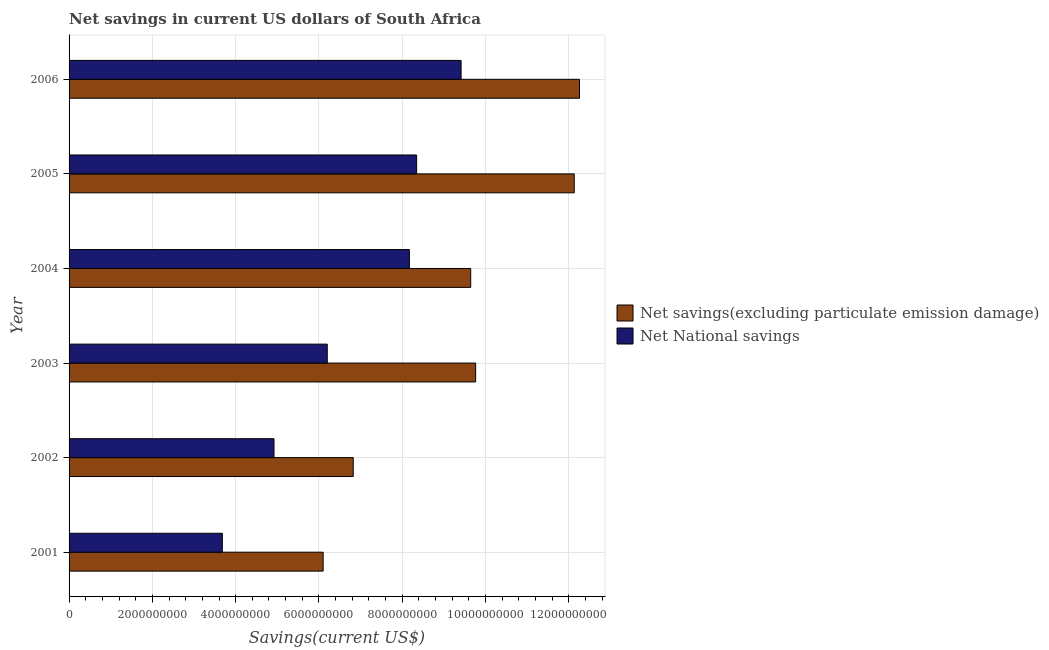Are the number of bars on each tick of the Y-axis equal?
Your response must be concise. Yes. In how many cases, is the number of bars for a given year not equal to the number of legend labels?
Your answer should be compact. 0. What is the net national savings in 2005?
Ensure brevity in your answer.  8.35e+09. Across all years, what is the maximum net savings(excluding particulate emission damage)?
Offer a very short reply. 1.23e+1. Across all years, what is the minimum net national savings?
Offer a terse response. 3.68e+09. What is the total net savings(excluding particulate emission damage) in the graph?
Ensure brevity in your answer.  5.67e+1. What is the difference between the net savings(excluding particulate emission damage) in 2003 and that in 2005?
Your answer should be very brief. -2.37e+09. What is the difference between the net national savings in 2002 and the net savings(excluding particulate emission damage) in 2005?
Provide a short and direct response. -7.21e+09. What is the average net national savings per year?
Give a very brief answer. 6.79e+09. In the year 2006, what is the difference between the net savings(excluding particulate emission damage) and net national savings?
Offer a terse response. 2.84e+09. What is the ratio of the net savings(excluding particulate emission damage) in 2001 to that in 2004?
Make the answer very short. 0.63. What is the difference between the highest and the second highest net national savings?
Make the answer very short. 1.07e+09. What is the difference between the highest and the lowest net national savings?
Provide a succinct answer. 5.73e+09. What does the 2nd bar from the top in 2003 represents?
Your answer should be compact. Net savings(excluding particulate emission damage). What does the 1st bar from the bottom in 2005 represents?
Your answer should be very brief. Net savings(excluding particulate emission damage). How many bars are there?
Provide a short and direct response. 12. What is the difference between two consecutive major ticks on the X-axis?
Provide a short and direct response. 2.00e+09. Does the graph contain any zero values?
Provide a succinct answer. No. How are the legend labels stacked?
Ensure brevity in your answer.  Vertical. What is the title of the graph?
Your answer should be very brief. Net savings in current US dollars of South Africa. What is the label or title of the X-axis?
Keep it short and to the point. Savings(current US$). What is the label or title of the Y-axis?
Provide a short and direct response. Year. What is the Savings(current US$) in Net savings(excluding particulate emission damage) in 2001?
Provide a succinct answer. 6.10e+09. What is the Savings(current US$) in Net National savings in 2001?
Your answer should be compact. 3.68e+09. What is the Savings(current US$) in Net savings(excluding particulate emission damage) in 2002?
Make the answer very short. 6.82e+09. What is the Savings(current US$) in Net National savings in 2002?
Offer a very short reply. 4.92e+09. What is the Savings(current US$) in Net savings(excluding particulate emission damage) in 2003?
Your answer should be compact. 9.76e+09. What is the Savings(current US$) in Net National savings in 2003?
Offer a terse response. 6.20e+09. What is the Savings(current US$) in Net savings(excluding particulate emission damage) in 2004?
Keep it short and to the point. 9.64e+09. What is the Savings(current US$) of Net National savings in 2004?
Ensure brevity in your answer.  8.17e+09. What is the Savings(current US$) of Net savings(excluding particulate emission damage) in 2005?
Provide a short and direct response. 1.21e+1. What is the Savings(current US$) in Net National savings in 2005?
Provide a short and direct response. 8.35e+09. What is the Savings(current US$) of Net savings(excluding particulate emission damage) in 2006?
Keep it short and to the point. 1.23e+1. What is the Savings(current US$) in Net National savings in 2006?
Your answer should be compact. 9.41e+09. Across all years, what is the maximum Savings(current US$) of Net savings(excluding particulate emission damage)?
Make the answer very short. 1.23e+1. Across all years, what is the maximum Savings(current US$) of Net National savings?
Your response must be concise. 9.41e+09. Across all years, what is the minimum Savings(current US$) in Net savings(excluding particulate emission damage)?
Give a very brief answer. 6.10e+09. Across all years, what is the minimum Savings(current US$) in Net National savings?
Provide a succinct answer. 3.68e+09. What is the total Savings(current US$) in Net savings(excluding particulate emission damage) in the graph?
Offer a very short reply. 5.67e+1. What is the total Savings(current US$) in Net National savings in the graph?
Provide a short and direct response. 4.07e+1. What is the difference between the Savings(current US$) of Net savings(excluding particulate emission damage) in 2001 and that in 2002?
Give a very brief answer. -7.22e+08. What is the difference between the Savings(current US$) of Net National savings in 2001 and that in 2002?
Make the answer very short. -1.24e+09. What is the difference between the Savings(current US$) in Net savings(excluding particulate emission damage) in 2001 and that in 2003?
Your answer should be compact. -3.66e+09. What is the difference between the Savings(current US$) in Net National savings in 2001 and that in 2003?
Give a very brief answer. -2.52e+09. What is the difference between the Savings(current US$) in Net savings(excluding particulate emission damage) in 2001 and that in 2004?
Provide a short and direct response. -3.54e+09. What is the difference between the Savings(current US$) of Net National savings in 2001 and that in 2004?
Give a very brief answer. -4.49e+09. What is the difference between the Savings(current US$) in Net savings(excluding particulate emission damage) in 2001 and that in 2005?
Provide a succinct answer. -6.03e+09. What is the difference between the Savings(current US$) of Net National savings in 2001 and that in 2005?
Your answer should be compact. -4.66e+09. What is the difference between the Savings(current US$) of Net savings(excluding particulate emission damage) in 2001 and that in 2006?
Keep it short and to the point. -6.16e+09. What is the difference between the Savings(current US$) in Net National savings in 2001 and that in 2006?
Offer a terse response. -5.73e+09. What is the difference between the Savings(current US$) of Net savings(excluding particulate emission damage) in 2002 and that in 2003?
Provide a succinct answer. -2.94e+09. What is the difference between the Savings(current US$) in Net National savings in 2002 and that in 2003?
Give a very brief answer. -1.28e+09. What is the difference between the Savings(current US$) in Net savings(excluding particulate emission damage) in 2002 and that in 2004?
Your answer should be very brief. -2.82e+09. What is the difference between the Savings(current US$) in Net National savings in 2002 and that in 2004?
Give a very brief answer. -3.25e+09. What is the difference between the Savings(current US$) of Net savings(excluding particulate emission damage) in 2002 and that in 2005?
Your response must be concise. -5.31e+09. What is the difference between the Savings(current US$) of Net National savings in 2002 and that in 2005?
Ensure brevity in your answer.  -3.42e+09. What is the difference between the Savings(current US$) in Net savings(excluding particulate emission damage) in 2002 and that in 2006?
Keep it short and to the point. -5.43e+09. What is the difference between the Savings(current US$) in Net National savings in 2002 and that in 2006?
Give a very brief answer. -4.49e+09. What is the difference between the Savings(current US$) in Net savings(excluding particulate emission damage) in 2003 and that in 2004?
Offer a terse response. 1.19e+08. What is the difference between the Savings(current US$) of Net National savings in 2003 and that in 2004?
Your answer should be compact. -1.97e+09. What is the difference between the Savings(current US$) in Net savings(excluding particulate emission damage) in 2003 and that in 2005?
Your response must be concise. -2.37e+09. What is the difference between the Savings(current US$) in Net National savings in 2003 and that in 2005?
Keep it short and to the point. -2.15e+09. What is the difference between the Savings(current US$) of Net savings(excluding particulate emission damage) in 2003 and that in 2006?
Offer a terse response. -2.49e+09. What is the difference between the Savings(current US$) in Net National savings in 2003 and that in 2006?
Give a very brief answer. -3.21e+09. What is the difference between the Savings(current US$) of Net savings(excluding particulate emission damage) in 2004 and that in 2005?
Your answer should be very brief. -2.49e+09. What is the difference between the Savings(current US$) of Net National savings in 2004 and that in 2005?
Offer a terse response. -1.74e+08. What is the difference between the Savings(current US$) in Net savings(excluding particulate emission damage) in 2004 and that in 2006?
Ensure brevity in your answer.  -2.61e+09. What is the difference between the Savings(current US$) in Net National savings in 2004 and that in 2006?
Provide a succinct answer. -1.24e+09. What is the difference between the Savings(current US$) in Net savings(excluding particulate emission damage) in 2005 and that in 2006?
Your answer should be very brief. -1.26e+08. What is the difference between the Savings(current US$) of Net National savings in 2005 and that in 2006?
Give a very brief answer. -1.07e+09. What is the difference between the Savings(current US$) in Net savings(excluding particulate emission damage) in 2001 and the Savings(current US$) in Net National savings in 2002?
Provide a succinct answer. 1.18e+09. What is the difference between the Savings(current US$) of Net savings(excluding particulate emission damage) in 2001 and the Savings(current US$) of Net National savings in 2003?
Ensure brevity in your answer.  -9.90e+07. What is the difference between the Savings(current US$) of Net savings(excluding particulate emission damage) in 2001 and the Savings(current US$) of Net National savings in 2004?
Give a very brief answer. -2.07e+09. What is the difference between the Savings(current US$) in Net savings(excluding particulate emission damage) in 2001 and the Savings(current US$) in Net National savings in 2005?
Give a very brief answer. -2.24e+09. What is the difference between the Savings(current US$) of Net savings(excluding particulate emission damage) in 2001 and the Savings(current US$) of Net National savings in 2006?
Keep it short and to the point. -3.31e+09. What is the difference between the Savings(current US$) of Net savings(excluding particulate emission damage) in 2002 and the Savings(current US$) of Net National savings in 2003?
Give a very brief answer. 6.23e+08. What is the difference between the Savings(current US$) of Net savings(excluding particulate emission damage) in 2002 and the Savings(current US$) of Net National savings in 2004?
Keep it short and to the point. -1.35e+09. What is the difference between the Savings(current US$) of Net savings(excluding particulate emission damage) in 2002 and the Savings(current US$) of Net National savings in 2005?
Ensure brevity in your answer.  -1.52e+09. What is the difference between the Savings(current US$) in Net savings(excluding particulate emission damage) in 2002 and the Savings(current US$) in Net National savings in 2006?
Your answer should be compact. -2.59e+09. What is the difference between the Savings(current US$) in Net savings(excluding particulate emission damage) in 2003 and the Savings(current US$) in Net National savings in 2004?
Give a very brief answer. 1.59e+09. What is the difference between the Savings(current US$) of Net savings(excluding particulate emission damage) in 2003 and the Savings(current US$) of Net National savings in 2005?
Give a very brief answer. 1.42e+09. What is the difference between the Savings(current US$) of Net savings(excluding particulate emission damage) in 2003 and the Savings(current US$) of Net National savings in 2006?
Your response must be concise. 3.49e+08. What is the difference between the Savings(current US$) of Net savings(excluding particulate emission damage) in 2004 and the Savings(current US$) of Net National savings in 2005?
Give a very brief answer. 1.30e+09. What is the difference between the Savings(current US$) of Net savings(excluding particulate emission damage) in 2004 and the Savings(current US$) of Net National savings in 2006?
Make the answer very short. 2.31e+08. What is the difference between the Savings(current US$) of Net savings(excluding particulate emission damage) in 2005 and the Savings(current US$) of Net National savings in 2006?
Your answer should be compact. 2.72e+09. What is the average Savings(current US$) in Net savings(excluding particulate emission damage) per year?
Make the answer very short. 9.45e+09. What is the average Savings(current US$) of Net National savings per year?
Ensure brevity in your answer.  6.79e+09. In the year 2001, what is the difference between the Savings(current US$) of Net savings(excluding particulate emission damage) and Savings(current US$) of Net National savings?
Ensure brevity in your answer.  2.42e+09. In the year 2002, what is the difference between the Savings(current US$) in Net savings(excluding particulate emission damage) and Savings(current US$) in Net National savings?
Your response must be concise. 1.90e+09. In the year 2003, what is the difference between the Savings(current US$) of Net savings(excluding particulate emission damage) and Savings(current US$) of Net National savings?
Your answer should be compact. 3.56e+09. In the year 2004, what is the difference between the Savings(current US$) of Net savings(excluding particulate emission damage) and Savings(current US$) of Net National savings?
Provide a short and direct response. 1.47e+09. In the year 2005, what is the difference between the Savings(current US$) in Net savings(excluding particulate emission damage) and Savings(current US$) in Net National savings?
Provide a succinct answer. 3.78e+09. In the year 2006, what is the difference between the Savings(current US$) in Net savings(excluding particulate emission damage) and Savings(current US$) in Net National savings?
Offer a terse response. 2.84e+09. What is the ratio of the Savings(current US$) in Net savings(excluding particulate emission damage) in 2001 to that in 2002?
Keep it short and to the point. 0.89. What is the ratio of the Savings(current US$) of Net National savings in 2001 to that in 2002?
Your response must be concise. 0.75. What is the ratio of the Savings(current US$) of Net savings(excluding particulate emission damage) in 2001 to that in 2003?
Offer a terse response. 0.62. What is the ratio of the Savings(current US$) of Net National savings in 2001 to that in 2003?
Your answer should be compact. 0.59. What is the ratio of the Savings(current US$) in Net savings(excluding particulate emission damage) in 2001 to that in 2004?
Provide a short and direct response. 0.63. What is the ratio of the Savings(current US$) in Net National savings in 2001 to that in 2004?
Provide a short and direct response. 0.45. What is the ratio of the Savings(current US$) of Net savings(excluding particulate emission damage) in 2001 to that in 2005?
Make the answer very short. 0.5. What is the ratio of the Savings(current US$) in Net National savings in 2001 to that in 2005?
Provide a short and direct response. 0.44. What is the ratio of the Savings(current US$) of Net savings(excluding particulate emission damage) in 2001 to that in 2006?
Your answer should be very brief. 0.5. What is the ratio of the Savings(current US$) of Net National savings in 2001 to that in 2006?
Your answer should be compact. 0.39. What is the ratio of the Savings(current US$) in Net savings(excluding particulate emission damage) in 2002 to that in 2003?
Your response must be concise. 0.7. What is the ratio of the Savings(current US$) in Net National savings in 2002 to that in 2003?
Your answer should be very brief. 0.79. What is the ratio of the Savings(current US$) of Net savings(excluding particulate emission damage) in 2002 to that in 2004?
Provide a succinct answer. 0.71. What is the ratio of the Savings(current US$) in Net National savings in 2002 to that in 2004?
Offer a very short reply. 0.6. What is the ratio of the Savings(current US$) in Net savings(excluding particulate emission damage) in 2002 to that in 2005?
Provide a short and direct response. 0.56. What is the ratio of the Savings(current US$) of Net National savings in 2002 to that in 2005?
Your response must be concise. 0.59. What is the ratio of the Savings(current US$) in Net savings(excluding particulate emission damage) in 2002 to that in 2006?
Your response must be concise. 0.56. What is the ratio of the Savings(current US$) in Net National savings in 2002 to that in 2006?
Offer a very short reply. 0.52. What is the ratio of the Savings(current US$) in Net savings(excluding particulate emission damage) in 2003 to that in 2004?
Provide a succinct answer. 1.01. What is the ratio of the Savings(current US$) of Net National savings in 2003 to that in 2004?
Provide a succinct answer. 0.76. What is the ratio of the Savings(current US$) of Net savings(excluding particulate emission damage) in 2003 to that in 2005?
Your answer should be very brief. 0.8. What is the ratio of the Savings(current US$) in Net National savings in 2003 to that in 2005?
Offer a terse response. 0.74. What is the ratio of the Savings(current US$) of Net savings(excluding particulate emission damage) in 2003 to that in 2006?
Provide a succinct answer. 0.8. What is the ratio of the Savings(current US$) of Net National savings in 2003 to that in 2006?
Ensure brevity in your answer.  0.66. What is the ratio of the Savings(current US$) in Net savings(excluding particulate emission damage) in 2004 to that in 2005?
Keep it short and to the point. 0.8. What is the ratio of the Savings(current US$) of Net National savings in 2004 to that in 2005?
Ensure brevity in your answer.  0.98. What is the ratio of the Savings(current US$) in Net savings(excluding particulate emission damage) in 2004 to that in 2006?
Give a very brief answer. 0.79. What is the ratio of the Savings(current US$) in Net National savings in 2004 to that in 2006?
Your answer should be compact. 0.87. What is the ratio of the Savings(current US$) of Net National savings in 2005 to that in 2006?
Offer a very short reply. 0.89. What is the difference between the highest and the second highest Savings(current US$) of Net savings(excluding particulate emission damage)?
Provide a succinct answer. 1.26e+08. What is the difference between the highest and the second highest Savings(current US$) in Net National savings?
Give a very brief answer. 1.07e+09. What is the difference between the highest and the lowest Savings(current US$) of Net savings(excluding particulate emission damage)?
Provide a short and direct response. 6.16e+09. What is the difference between the highest and the lowest Savings(current US$) in Net National savings?
Your answer should be compact. 5.73e+09. 